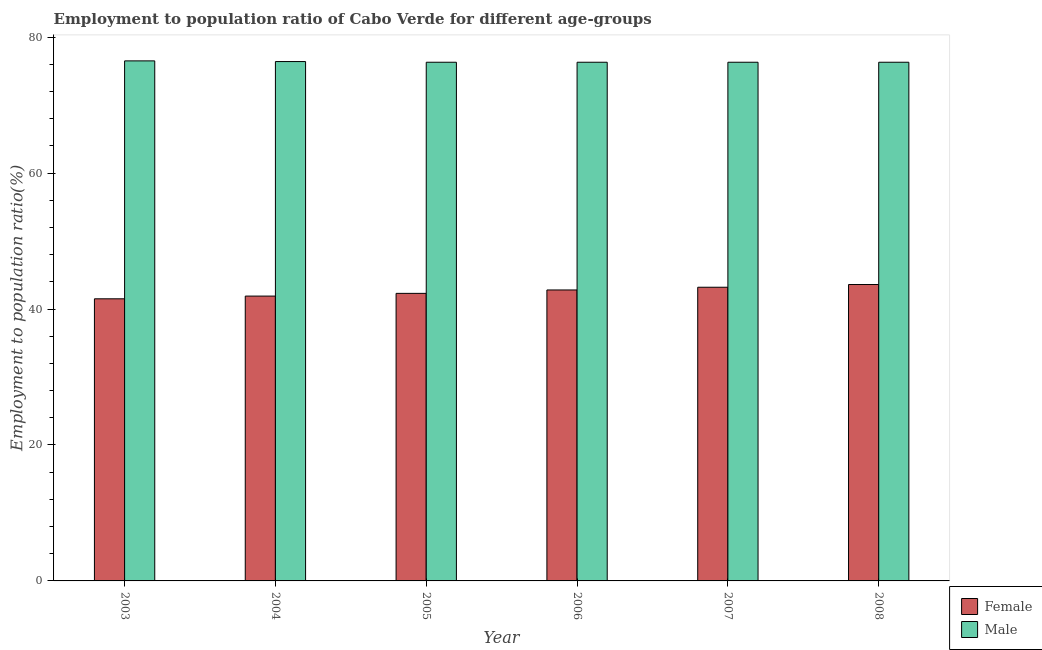How many different coloured bars are there?
Provide a succinct answer. 2. Are the number of bars on each tick of the X-axis equal?
Keep it short and to the point. Yes. In how many cases, is the number of bars for a given year not equal to the number of legend labels?
Ensure brevity in your answer.  0. What is the employment to population ratio(female) in 2007?
Your answer should be compact. 43.2. Across all years, what is the maximum employment to population ratio(male)?
Your response must be concise. 76.5. Across all years, what is the minimum employment to population ratio(female)?
Offer a very short reply. 41.5. In which year was the employment to population ratio(male) maximum?
Your answer should be compact. 2003. What is the total employment to population ratio(female) in the graph?
Your answer should be compact. 255.3. What is the difference between the employment to population ratio(female) in 2005 and the employment to population ratio(male) in 2007?
Offer a terse response. -0.9. What is the average employment to population ratio(female) per year?
Provide a succinct answer. 42.55. What is the ratio of the employment to population ratio(male) in 2005 to that in 2008?
Keep it short and to the point. 1. Is the difference between the employment to population ratio(female) in 2003 and 2008 greater than the difference between the employment to population ratio(male) in 2003 and 2008?
Provide a short and direct response. No. What is the difference between the highest and the second highest employment to population ratio(male)?
Make the answer very short. 0.1. What is the difference between the highest and the lowest employment to population ratio(female)?
Make the answer very short. 2.1. In how many years, is the employment to population ratio(male) greater than the average employment to population ratio(male) taken over all years?
Your answer should be very brief. 2. What does the 1st bar from the right in 2003 represents?
Give a very brief answer. Male. How many bars are there?
Give a very brief answer. 12. Does the graph contain any zero values?
Keep it short and to the point. No. What is the title of the graph?
Keep it short and to the point. Employment to population ratio of Cabo Verde for different age-groups. Does "Domestic Liabilities" appear as one of the legend labels in the graph?
Provide a short and direct response. No. What is the label or title of the X-axis?
Your answer should be compact. Year. What is the label or title of the Y-axis?
Give a very brief answer. Employment to population ratio(%). What is the Employment to population ratio(%) of Female in 2003?
Your answer should be very brief. 41.5. What is the Employment to population ratio(%) in Male in 2003?
Your answer should be compact. 76.5. What is the Employment to population ratio(%) of Female in 2004?
Provide a succinct answer. 41.9. What is the Employment to population ratio(%) in Male in 2004?
Provide a short and direct response. 76.4. What is the Employment to population ratio(%) of Female in 2005?
Offer a very short reply. 42.3. What is the Employment to population ratio(%) in Male in 2005?
Provide a short and direct response. 76.3. What is the Employment to population ratio(%) in Female in 2006?
Your answer should be compact. 42.8. What is the Employment to population ratio(%) of Male in 2006?
Make the answer very short. 76.3. What is the Employment to population ratio(%) of Female in 2007?
Offer a very short reply. 43.2. What is the Employment to population ratio(%) in Male in 2007?
Your answer should be very brief. 76.3. What is the Employment to population ratio(%) in Female in 2008?
Ensure brevity in your answer.  43.6. What is the Employment to population ratio(%) of Male in 2008?
Provide a short and direct response. 76.3. Across all years, what is the maximum Employment to population ratio(%) of Female?
Offer a very short reply. 43.6. Across all years, what is the maximum Employment to population ratio(%) of Male?
Offer a very short reply. 76.5. Across all years, what is the minimum Employment to population ratio(%) of Female?
Ensure brevity in your answer.  41.5. Across all years, what is the minimum Employment to population ratio(%) in Male?
Your answer should be compact. 76.3. What is the total Employment to population ratio(%) in Female in the graph?
Offer a very short reply. 255.3. What is the total Employment to population ratio(%) of Male in the graph?
Offer a terse response. 458.1. What is the difference between the Employment to population ratio(%) in Male in 2003 and that in 2004?
Offer a terse response. 0.1. What is the difference between the Employment to population ratio(%) of Female in 2003 and that in 2006?
Ensure brevity in your answer.  -1.3. What is the difference between the Employment to population ratio(%) of Male in 2003 and that in 2006?
Keep it short and to the point. 0.2. What is the difference between the Employment to population ratio(%) of Female in 2003 and that in 2007?
Your answer should be very brief. -1.7. What is the difference between the Employment to population ratio(%) of Male in 2003 and that in 2007?
Provide a short and direct response. 0.2. What is the difference between the Employment to population ratio(%) of Female in 2003 and that in 2008?
Your answer should be very brief. -2.1. What is the difference between the Employment to population ratio(%) of Male in 2003 and that in 2008?
Your response must be concise. 0.2. What is the difference between the Employment to population ratio(%) in Female in 2004 and that in 2006?
Your answer should be very brief. -0.9. What is the difference between the Employment to population ratio(%) in Male in 2004 and that in 2007?
Your response must be concise. 0.1. What is the difference between the Employment to population ratio(%) in Male in 2004 and that in 2008?
Your answer should be compact. 0.1. What is the difference between the Employment to population ratio(%) in Male in 2005 and that in 2006?
Offer a terse response. 0. What is the difference between the Employment to population ratio(%) in Female in 2005 and that in 2007?
Provide a short and direct response. -0.9. What is the difference between the Employment to population ratio(%) in Male in 2005 and that in 2007?
Give a very brief answer. 0. What is the difference between the Employment to population ratio(%) in Female in 2005 and that in 2008?
Provide a succinct answer. -1.3. What is the difference between the Employment to population ratio(%) of Male in 2005 and that in 2008?
Offer a terse response. 0. What is the difference between the Employment to population ratio(%) in Male in 2006 and that in 2007?
Your answer should be very brief. 0. What is the difference between the Employment to population ratio(%) of Male in 2006 and that in 2008?
Make the answer very short. 0. What is the difference between the Employment to population ratio(%) of Male in 2007 and that in 2008?
Offer a terse response. 0. What is the difference between the Employment to population ratio(%) of Female in 2003 and the Employment to population ratio(%) of Male in 2004?
Provide a short and direct response. -34.9. What is the difference between the Employment to population ratio(%) of Female in 2003 and the Employment to population ratio(%) of Male in 2005?
Your answer should be compact. -34.8. What is the difference between the Employment to population ratio(%) in Female in 2003 and the Employment to population ratio(%) in Male in 2006?
Keep it short and to the point. -34.8. What is the difference between the Employment to population ratio(%) of Female in 2003 and the Employment to population ratio(%) of Male in 2007?
Ensure brevity in your answer.  -34.8. What is the difference between the Employment to population ratio(%) in Female in 2003 and the Employment to population ratio(%) in Male in 2008?
Your response must be concise. -34.8. What is the difference between the Employment to population ratio(%) in Female in 2004 and the Employment to population ratio(%) in Male in 2005?
Offer a terse response. -34.4. What is the difference between the Employment to population ratio(%) in Female in 2004 and the Employment to population ratio(%) in Male in 2006?
Provide a short and direct response. -34.4. What is the difference between the Employment to population ratio(%) of Female in 2004 and the Employment to population ratio(%) of Male in 2007?
Provide a succinct answer. -34.4. What is the difference between the Employment to population ratio(%) of Female in 2004 and the Employment to population ratio(%) of Male in 2008?
Keep it short and to the point. -34.4. What is the difference between the Employment to population ratio(%) of Female in 2005 and the Employment to population ratio(%) of Male in 2006?
Keep it short and to the point. -34. What is the difference between the Employment to population ratio(%) of Female in 2005 and the Employment to population ratio(%) of Male in 2007?
Provide a succinct answer. -34. What is the difference between the Employment to population ratio(%) of Female in 2005 and the Employment to population ratio(%) of Male in 2008?
Offer a very short reply. -34. What is the difference between the Employment to population ratio(%) in Female in 2006 and the Employment to population ratio(%) in Male in 2007?
Your answer should be compact. -33.5. What is the difference between the Employment to population ratio(%) in Female in 2006 and the Employment to population ratio(%) in Male in 2008?
Offer a terse response. -33.5. What is the difference between the Employment to population ratio(%) in Female in 2007 and the Employment to population ratio(%) in Male in 2008?
Offer a very short reply. -33.1. What is the average Employment to population ratio(%) in Female per year?
Offer a terse response. 42.55. What is the average Employment to population ratio(%) of Male per year?
Your response must be concise. 76.35. In the year 2003, what is the difference between the Employment to population ratio(%) in Female and Employment to population ratio(%) in Male?
Your answer should be compact. -35. In the year 2004, what is the difference between the Employment to population ratio(%) in Female and Employment to population ratio(%) in Male?
Make the answer very short. -34.5. In the year 2005, what is the difference between the Employment to population ratio(%) in Female and Employment to population ratio(%) in Male?
Your answer should be very brief. -34. In the year 2006, what is the difference between the Employment to population ratio(%) in Female and Employment to population ratio(%) in Male?
Make the answer very short. -33.5. In the year 2007, what is the difference between the Employment to population ratio(%) of Female and Employment to population ratio(%) of Male?
Provide a succinct answer. -33.1. In the year 2008, what is the difference between the Employment to population ratio(%) in Female and Employment to population ratio(%) in Male?
Ensure brevity in your answer.  -32.7. What is the ratio of the Employment to population ratio(%) of Male in 2003 to that in 2004?
Offer a terse response. 1. What is the ratio of the Employment to population ratio(%) of Female in 2003 to that in 2005?
Your answer should be compact. 0.98. What is the ratio of the Employment to population ratio(%) in Female in 2003 to that in 2006?
Your response must be concise. 0.97. What is the ratio of the Employment to population ratio(%) of Male in 2003 to that in 2006?
Offer a terse response. 1. What is the ratio of the Employment to population ratio(%) in Female in 2003 to that in 2007?
Your answer should be very brief. 0.96. What is the ratio of the Employment to population ratio(%) in Female in 2003 to that in 2008?
Ensure brevity in your answer.  0.95. What is the ratio of the Employment to population ratio(%) of Female in 2004 to that in 2005?
Your answer should be compact. 0.99. What is the ratio of the Employment to population ratio(%) in Male in 2004 to that in 2005?
Keep it short and to the point. 1. What is the ratio of the Employment to population ratio(%) of Female in 2004 to that in 2006?
Ensure brevity in your answer.  0.98. What is the ratio of the Employment to population ratio(%) of Female in 2004 to that in 2007?
Your answer should be compact. 0.97. What is the ratio of the Employment to population ratio(%) in Female in 2004 to that in 2008?
Make the answer very short. 0.96. What is the ratio of the Employment to population ratio(%) in Female in 2005 to that in 2006?
Provide a succinct answer. 0.99. What is the ratio of the Employment to population ratio(%) of Male in 2005 to that in 2006?
Provide a succinct answer. 1. What is the ratio of the Employment to population ratio(%) in Female in 2005 to that in 2007?
Your answer should be very brief. 0.98. What is the ratio of the Employment to population ratio(%) of Male in 2005 to that in 2007?
Your answer should be compact. 1. What is the ratio of the Employment to population ratio(%) of Female in 2005 to that in 2008?
Your answer should be very brief. 0.97. What is the ratio of the Employment to population ratio(%) in Female in 2006 to that in 2007?
Your answer should be compact. 0.99. What is the ratio of the Employment to population ratio(%) of Female in 2006 to that in 2008?
Your answer should be compact. 0.98. What is the ratio of the Employment to population ratio(%) of Male in 2006 to that in 2008?
Keep it short and to the point. 1. What is the ratio of the Employment to population ratio(%) in Female in 2007 to that in 2008?
Your response must be concise. 0.99. What is the difference between the highest and the lowest Employment to population ratio(%) in Male?
Offer a very short reply. 0.2. 